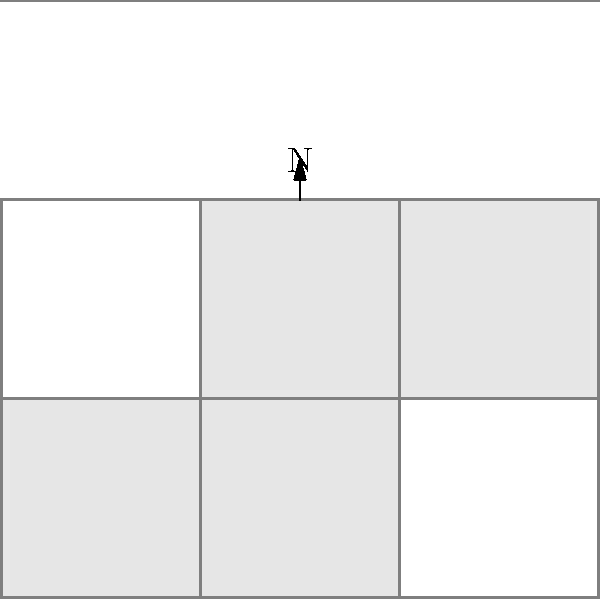Based on the aerial view of an archaeological site shown above, what letter of the alphabet does the shape of the excavation area most closely resemble? To identify the shape of the archaeological site from the aerial view, we need to follow these steps:

1. Observe the overall outline of the shaded area, which represents the excavation site.
2. Note that the site has a generally rectangular shape with an additional protrusion on one side.
3. The main body of the site forms a rectangle that is wider than it is tall.
4. There is an extension on the right side of the rectangle that creates an additional square area.
5. This combination of a wider rectangle with a square extension on one side closely resembles the shape of the capital letter "L" rotated 90 degrees clockwise.
6. The orientation of the site relative to the north arrow is not relevant for identifying the letter shape; we're focusing on the general form.

By analyzing these characteristics, we can conclude that the shape of the excavation area most closely resembles a rotated capital letter "L".
Answer: L 